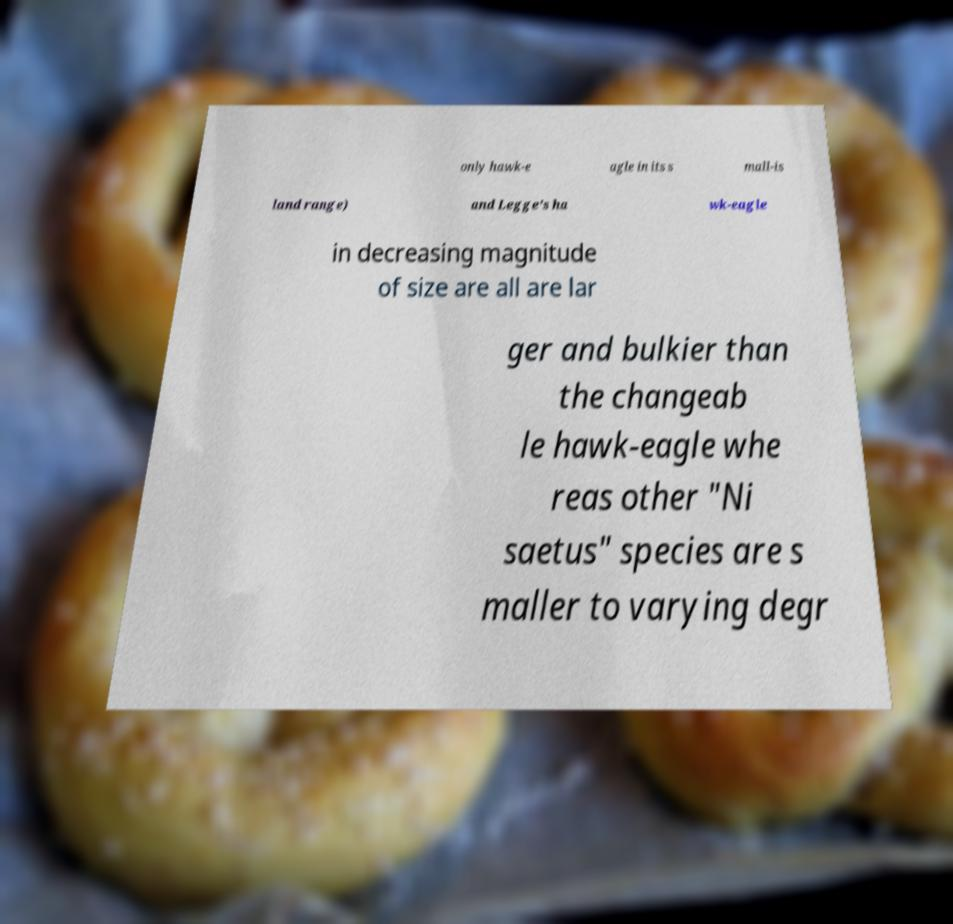Could you assist in decoding the text presented in this image and type it out clearly? only hawk-e agle in its s mall-is land range) and Legge's ha wk-eagle in decreasing magnitude of size are all are lar ger and bulkier than the changeab le hawk-eagle whe reas other "Ni saetus" species are s maller to varying degr 